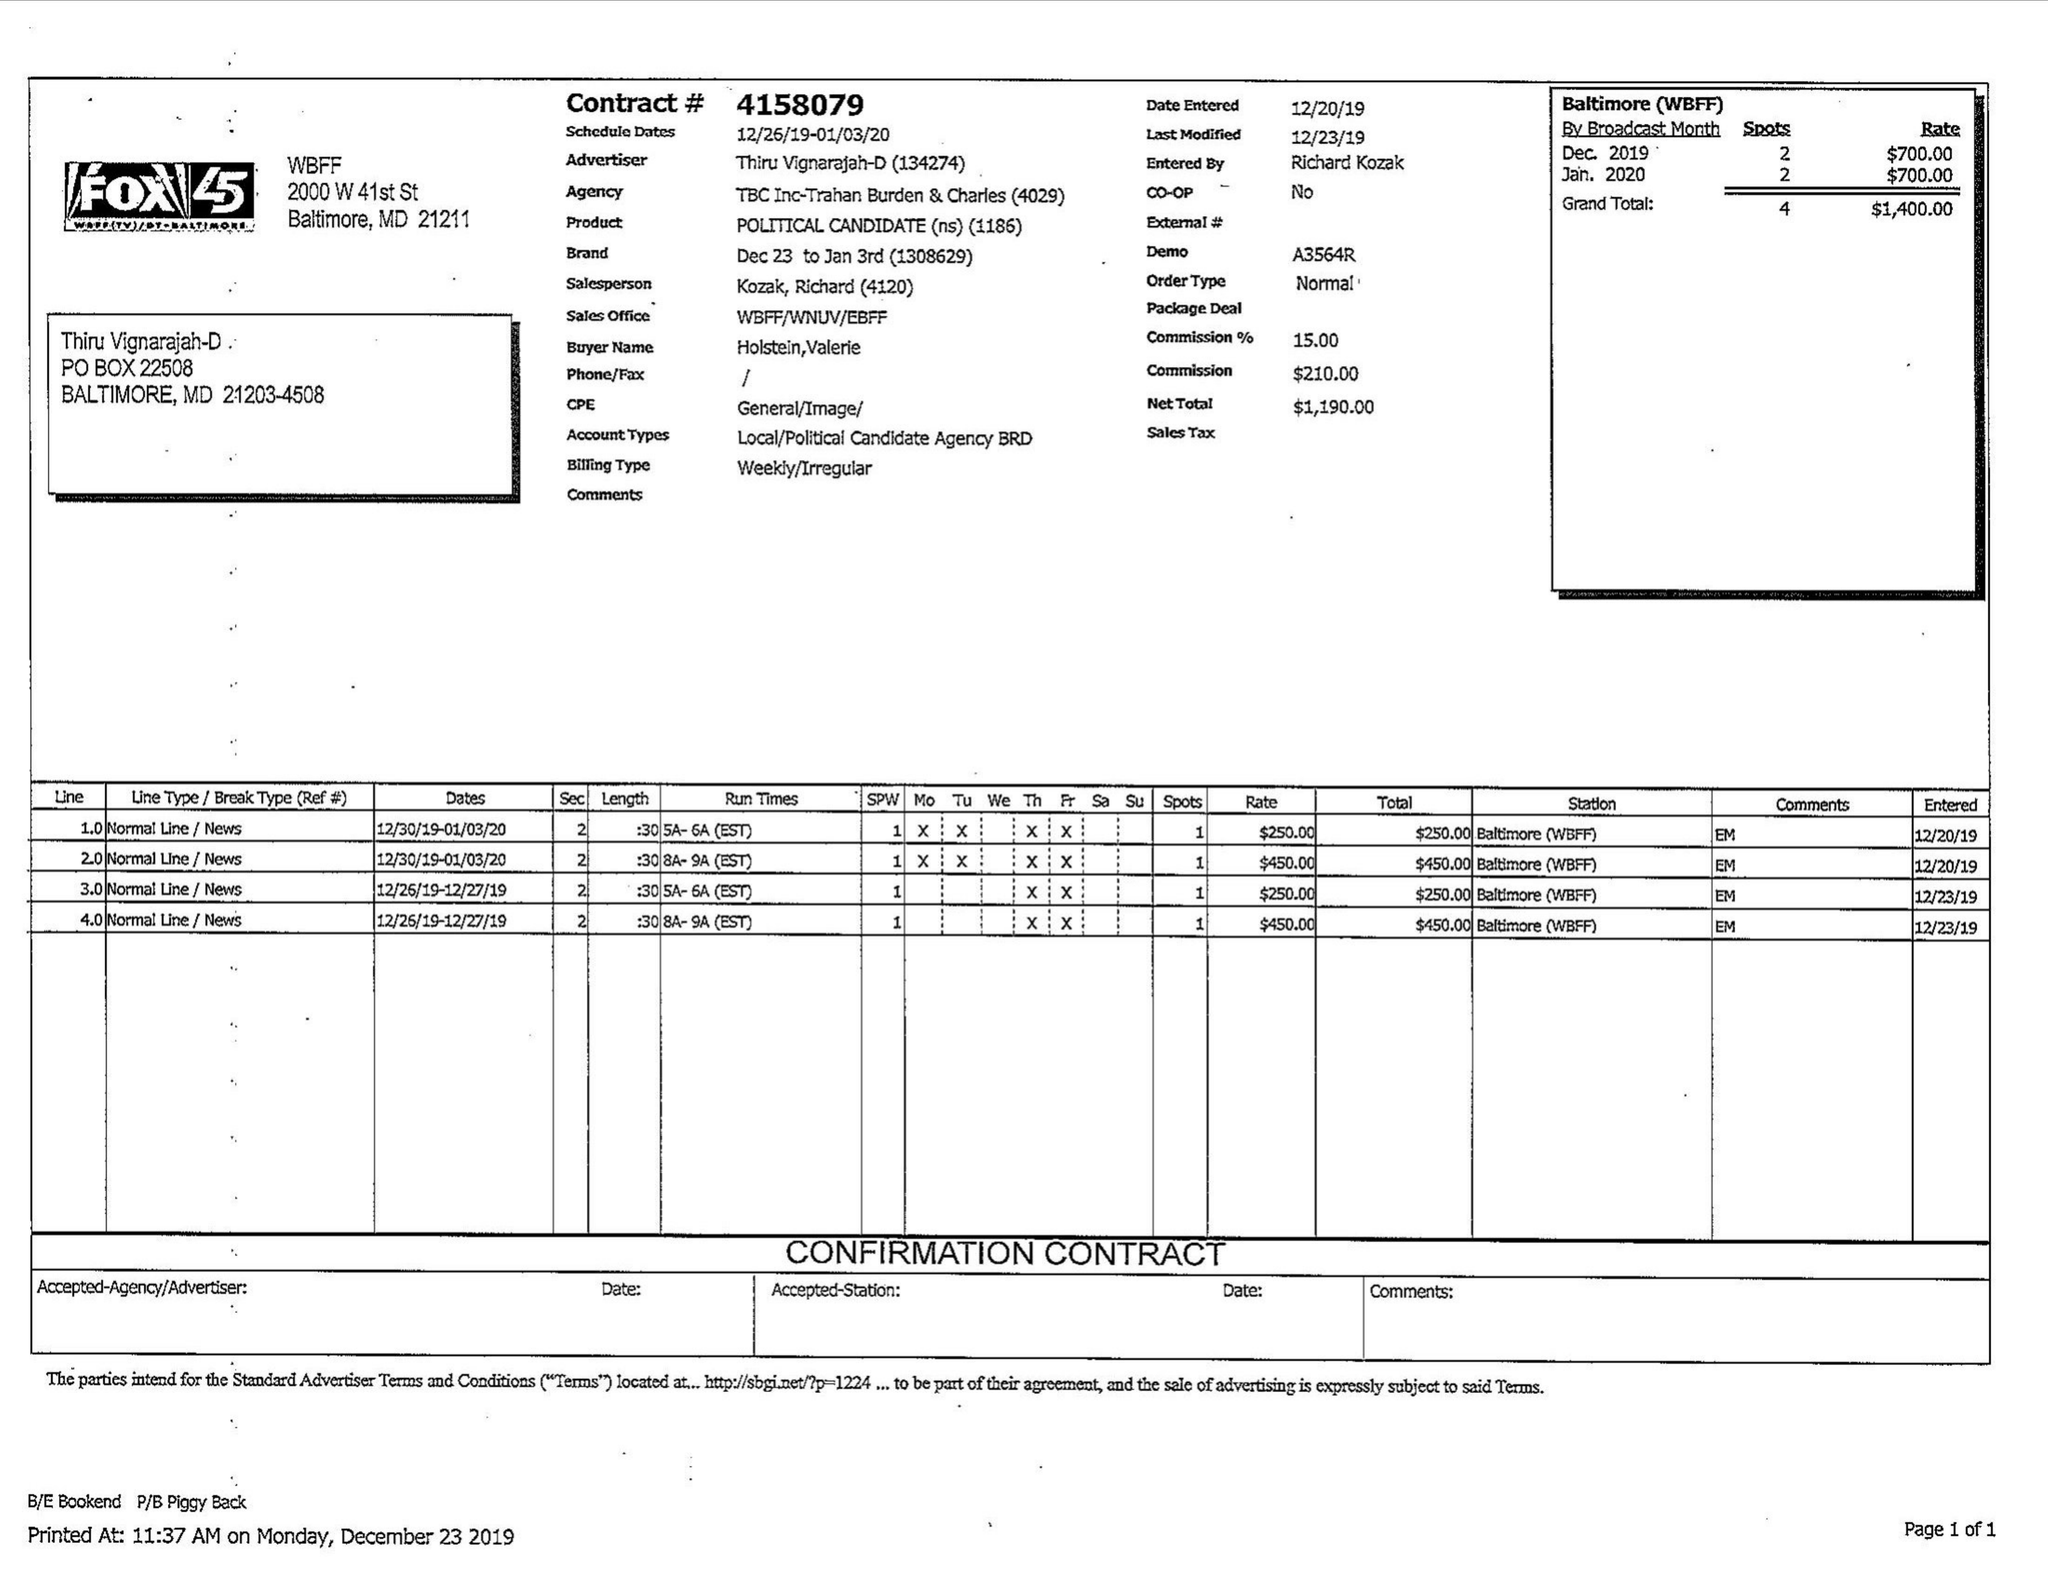What is the value for the flight_from?
Answer the question using a single word or phrase. 12/26/19 